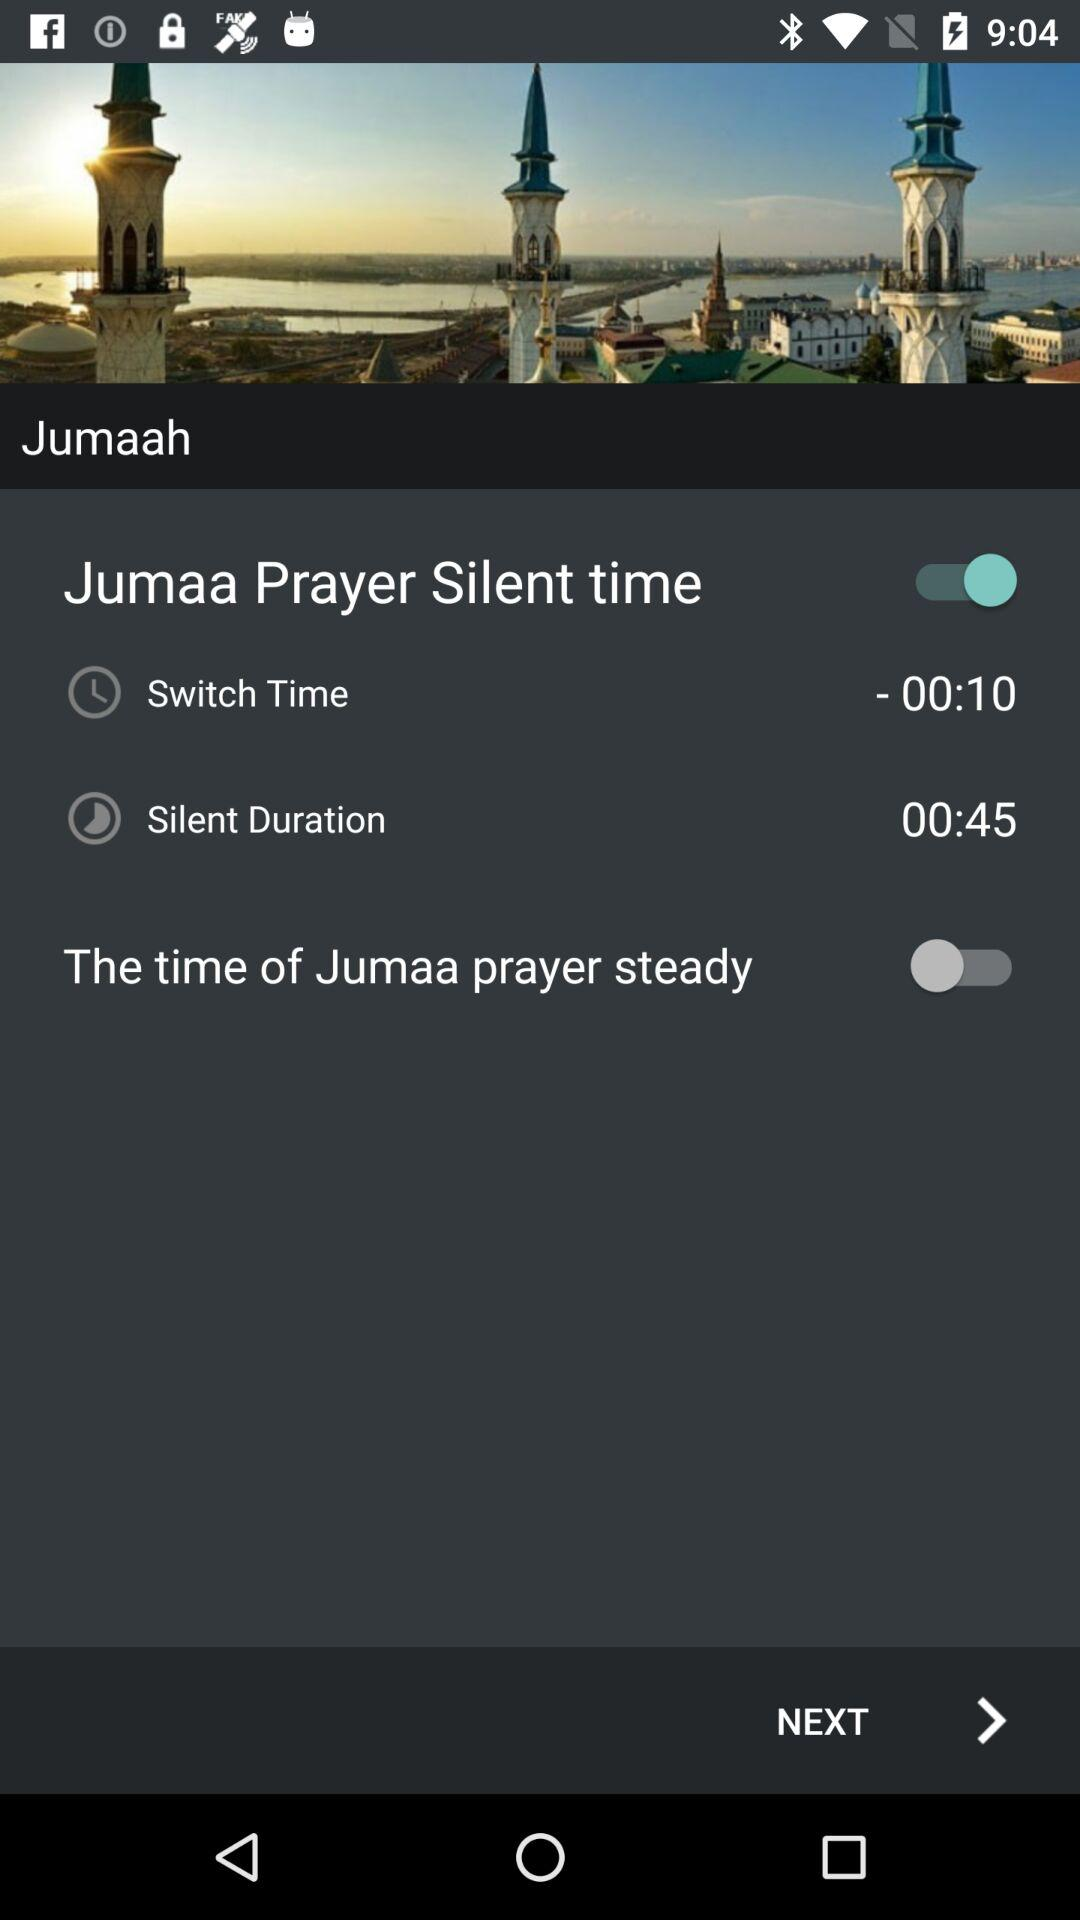How much longer is the silent duration than the switch time?
Answer the question using a single word or phrase. 00:35 